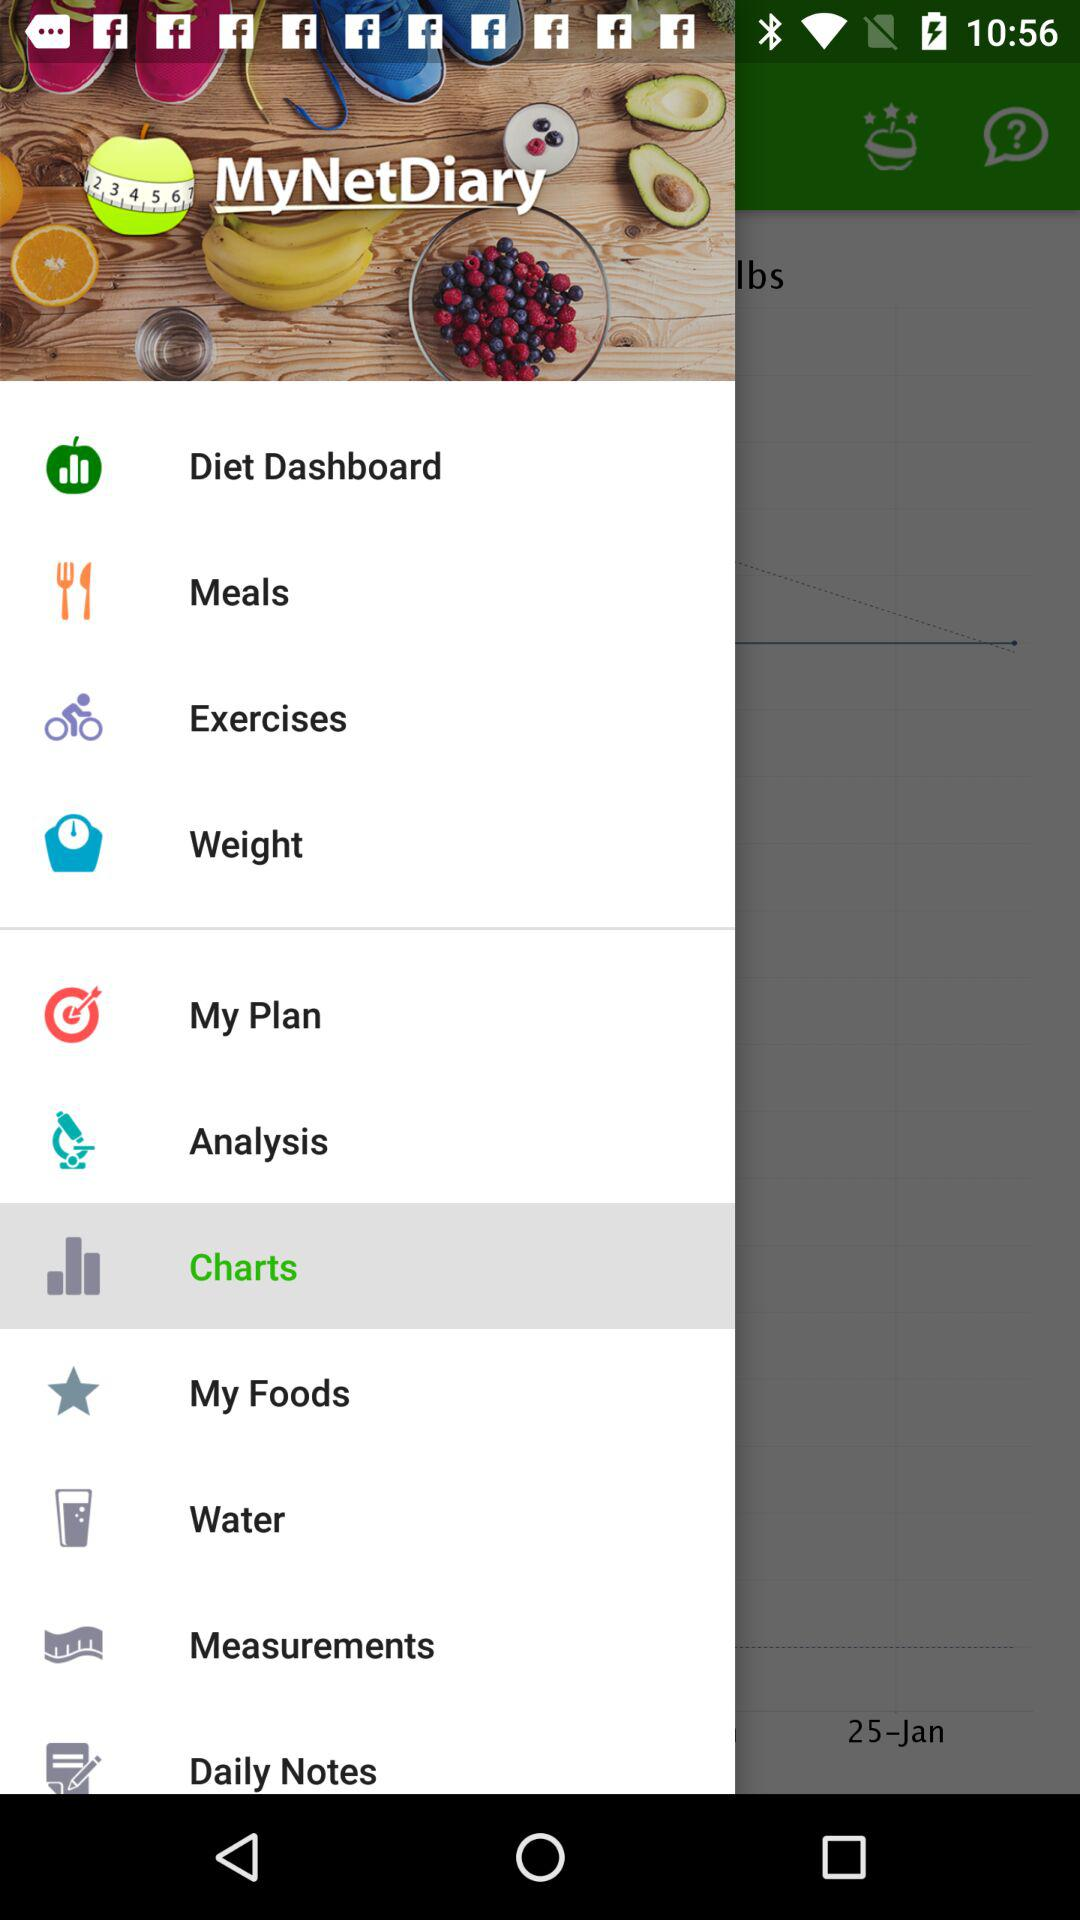What is the application name? The application name is "MyNetDiary". 